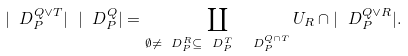<formula> <loc_0><loc_0><loc_500><loc_500>| \ D _ { P } ^ { Q \vee T } | \ | \ D _ { P } ^ { Q } | = \coprod _ { \emptyset \neq \ D _ { P } ^ { R } \subseteq \ D _ { P } ^ { T } \ \ D _ { P } ^ { Q \cap T } } U _ { R } \cap | \ D _ { P } ^ { Q \vee R } | .</formula> 